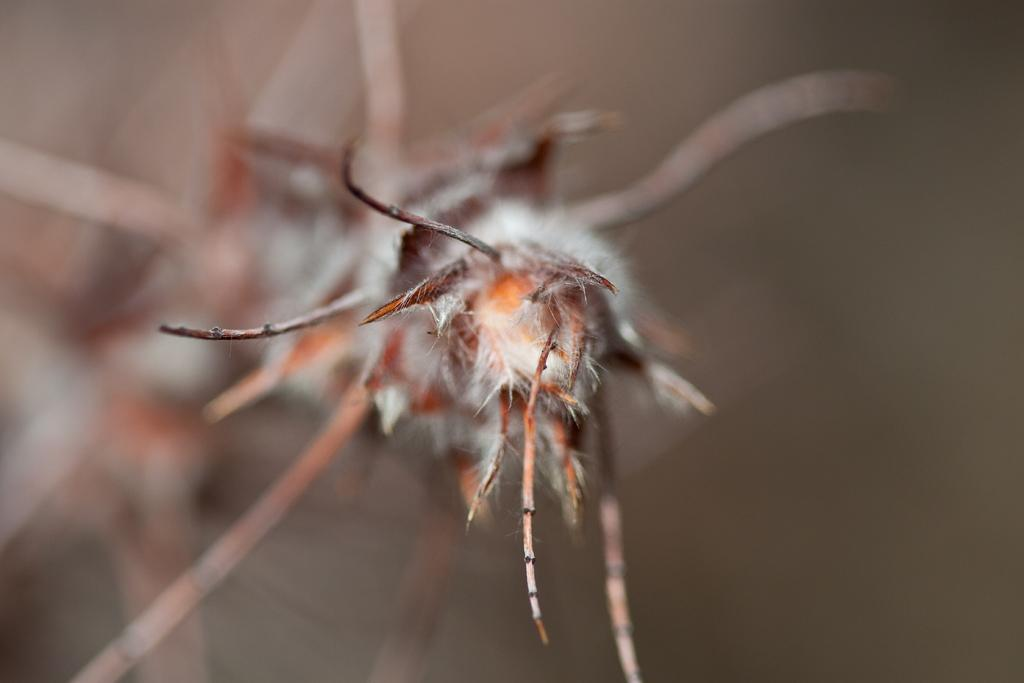What type of photograph is shown in the image? The image is a macro photograph. What is the main subject of the macro photograph? The subject of the photograph is an insect. Where is the nearest hospital to the insect in the image? The image does not provide information about the location of a hospital, nor does it show any buildings or structures that would indicate a hospital's proximity. 